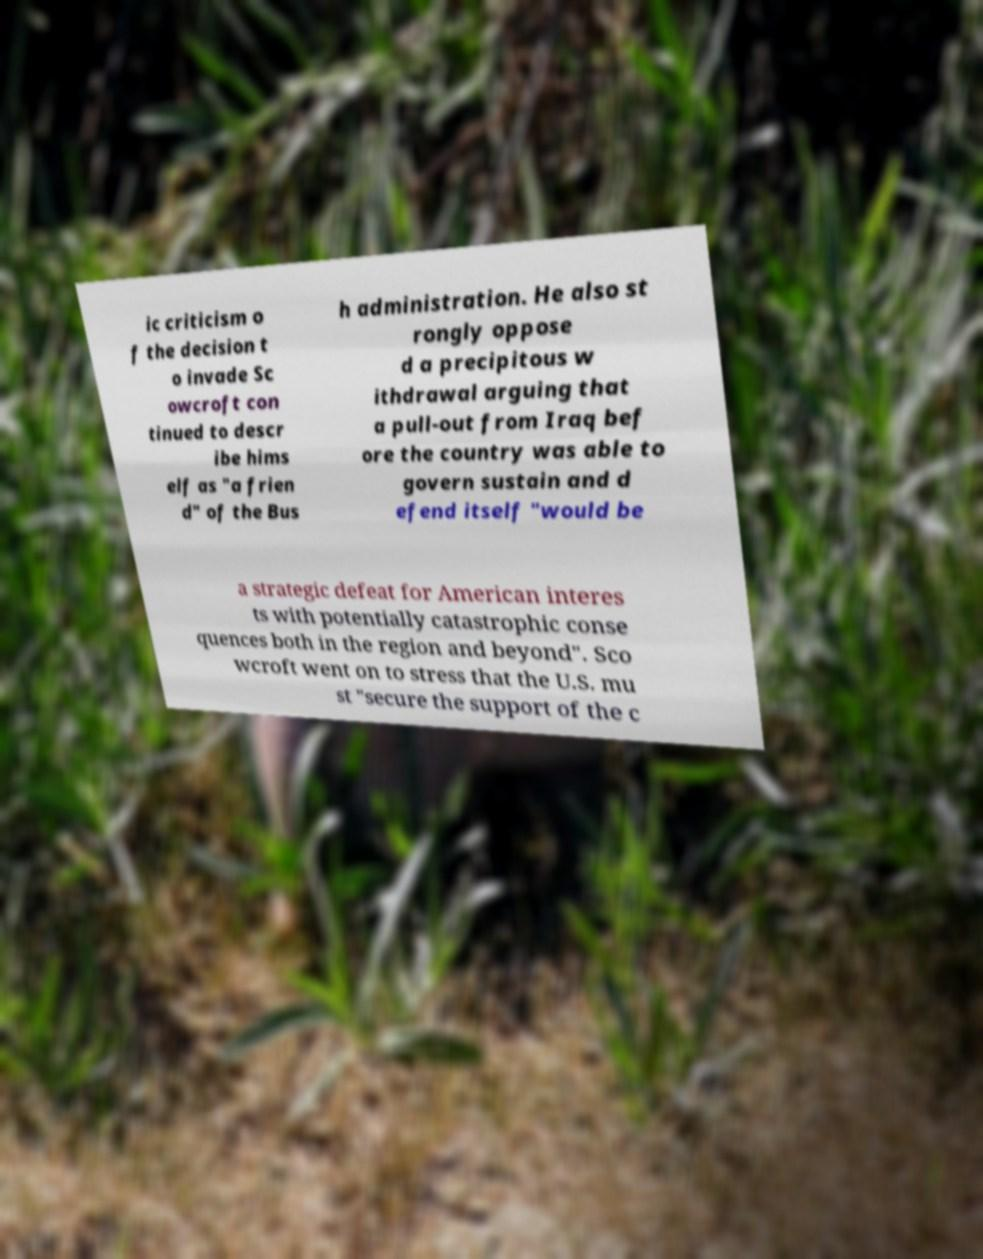Can you accurately transcribe the text from the provided image for me? ic criticism o f the decision t o invade Sc owcroft con tinued to descr ibe hims elf as "a frien d" of the Bus h administration. He also st rongly oppose d a precipitous w ithdrawal arguing that a pull-out from Iraq bef ore the country was able to govern sustain and d efend itself "would be a strategic defeat for American interes ts with potentially catastrophic conse quences both in the region and beyond". Sco wcroft went on to stress that the U.S. mu st "secure the support of the c 